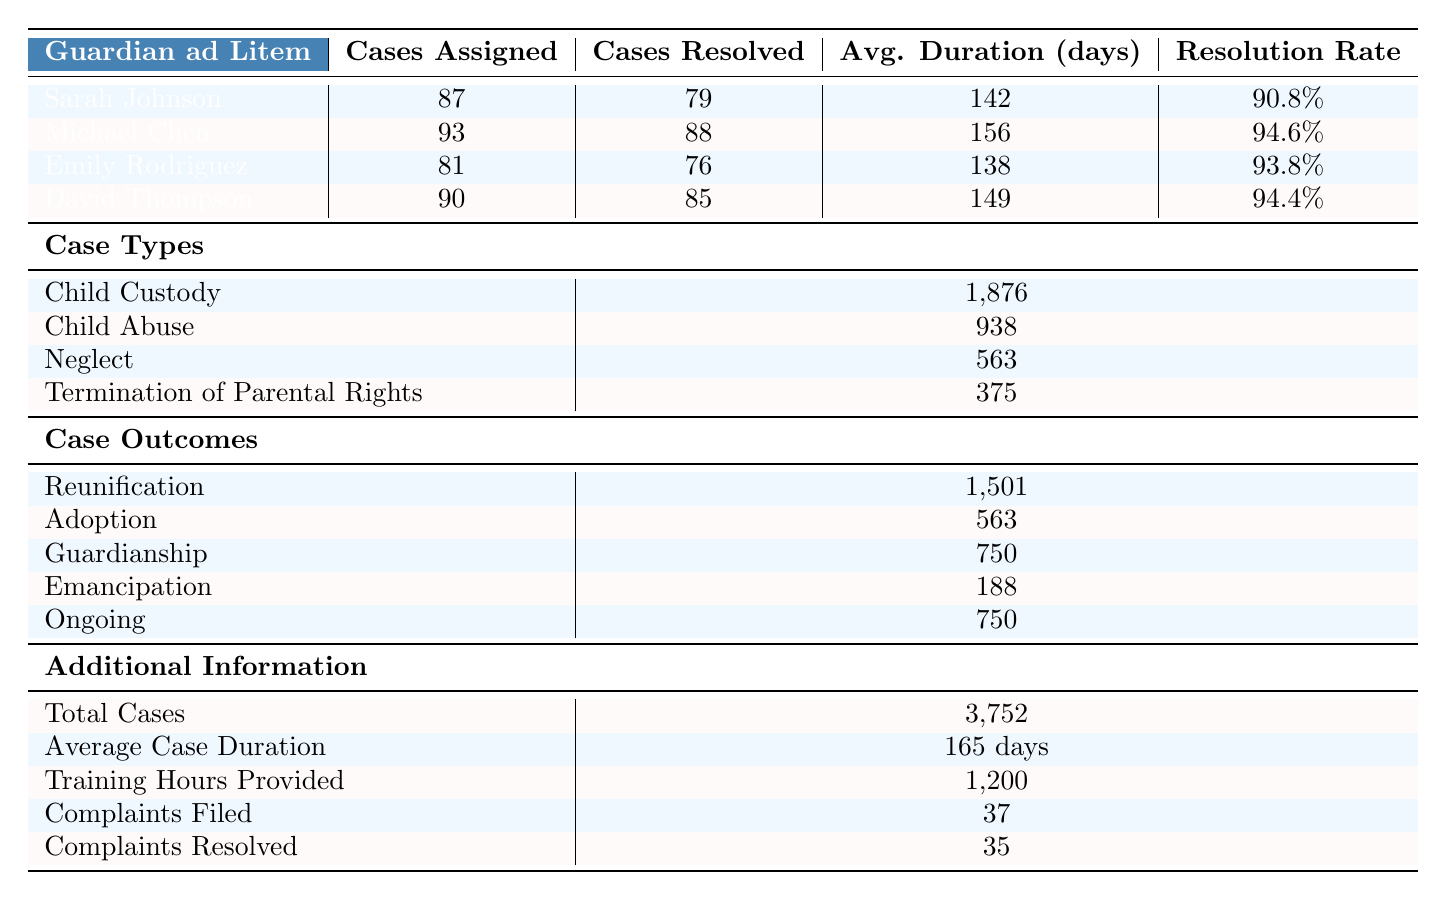What is the name of the Guardian ad Litem with the highest resolution rate? Michael Chen has the highest resolution rate of 94.6% among the guardians listed in the table.
Answer: Michael Chen How many total cases were assigned to all Guardian ad Litem? The total cases assigned can be calculated by adding the cases assigned to each guardian: (87 + 93 + 81 + 90) = 351.
Answer: 351 Which case type has the highest number of cases? The case type with the highest number of cases is Child Custody, with 1,876 cases assigned.
Answer: Child Custody What is the average case duration in days? The table specifies an average case duration of 165 days for all cases.
Answer: 165 days Did more complaints get resolved than filed? Yes, the number of complaints resolved (35) is greater than the number of complaints filed (37).
Answer: Yes What fraction of the total cases resulted in reunification? To find the fraction, divide the number of reunification cases (1,501) by the total cases (3,752). Thus, 1,501/3,752 ≈ 0.400.
Answer: Approximately 0.400 What percentage of cases assigned to Sarah Johnson were resolved? Sarah Johnson resolved 79 out of 87 assigned cases, so the resolution percentage is (79/87) × 100 = 90.8%.
Answer: 90.8% Which guardian had the shortest average case duration? Comparing the average case duration for all guardians shows that Emily Rodriguez had the shortest with 138 days.
Answer: Emily Rodriguez How many more cases of child custody were there compared to cases of neglect? The difference is calculated by subtracting the number of neglect cases (563) from child custody cases (1,876): 1,876 - 563 = 1,313.
Answer: 1,313 What is the total funding from state budget and federal grants combined? The total funding from both sources is calculated by adding the state budget ($7,500,000) and federal grants ($2,500,000): 7,500,000 + 2,500,000 = 10,000,000.
Answer: $10,000,000 